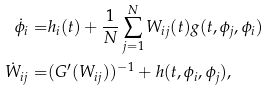<formula> <loc_0><loc_0><loc_500><loc_500>\dot { \phi } _ { i } = & h _ { i } ( t ) + \frac { 1 } { N } \sum _ { j = 1 } ^ { N } W _ { i j } ( t ) g ( t , \phi _ { j } , \phi _ { i } ) \\ \dot { W } _ { i j } = & ( G ^ { \prime } ( W _ { i j } ) ) ^ { - 1 } + h ( t , \phi _ { i } , \phi _ { j } ) ,</formula> 